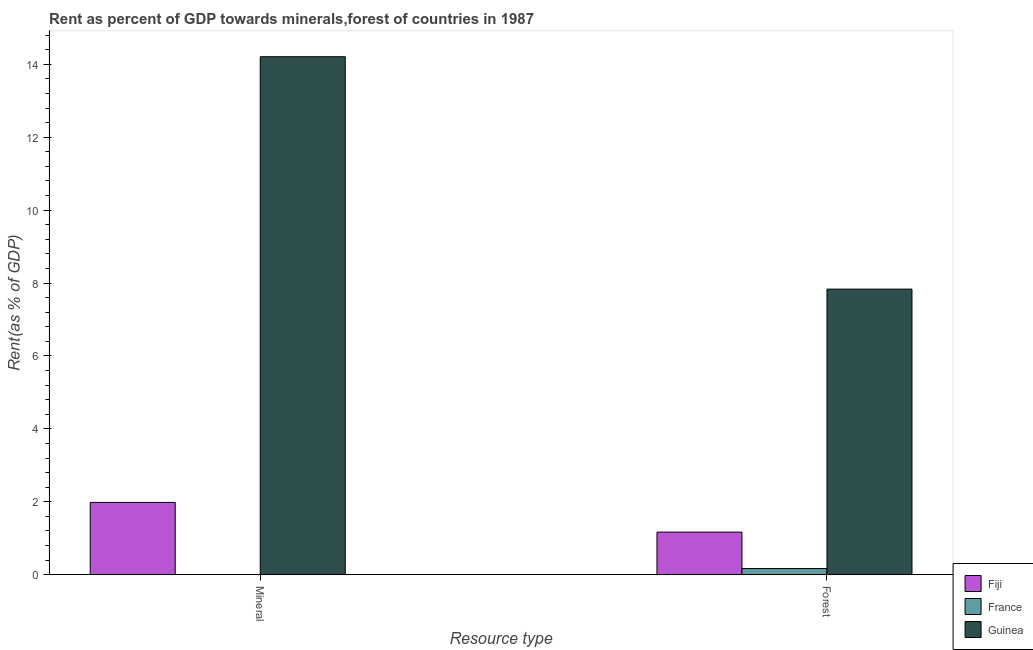How many different coloured bars are there?
Offer a very short reply. 3. How many groups of bars are there?
Offer a terse response. 2. Are the number of bars on each tick of the X-axis equal?
Your answer should be very brief. Yes. How many bars are there on the 1st tick from the left?
Offer a terse response. 3. How many bars are there on the 2nd tick from the right?
Provide a succinct answer. 3. What is the label of the 1st group of bars from the left?
Your answer should be compact. Mineral. What is the forest rent in France?
Provide a short and direct response. 0.17. Across all countries, what is the maximum forest rent?
Keep it short and to the point. 7.83. Across all countries, what is the minimum forest rent?
Provide a short and direct response. 0.17. In which country was the mineral rent maximum?
Give a very brief answer. Guinea. What is the total mineral rent in the graph?
Keep it short and to the point. 16.19. What is the difference between the forest rent in Guinea and that in Fiji?
Your response must be concise. 6.66. What is the difference between the mineral rent in Fiji and the forest rent in Guinea?
Ensure brevity in your answer.  -5.85. What is the average mineral rent per country?
Offer a very short reply. 5.4. What is the difference between the mineral rent and forest rent in Fiji?
Your answer should be compact. 0.81. What is the ratio of the forest rent in France to that in Guinea?
Make the answer very short. 0.02. What does the 3rd bar from the right in Forest represents?
Offer a terse response. Fiji. How many bars are there?
Provide a short and direct response. 6. How many countries are there in the graph?
Offer a terse response. 3. What is the difference between two consecutive major ticks on the Y-axis?
Keep it short and to the point. 2. Are the values on the major ticks of Y-axis written in scientific E-notation?
Make the answer very short. No. Where does the legend appear in the graph?
Ensure brevity in your answer.  Bottom right. How many legend labels are there?
Keep it short and to the point. 3. How are the legend labels stacked?
Provide a succinct answer. Vertical. What is the title of the graph?
Provide a succinct answer. Rent as percent of GDP towards minerals,forest of countries in 1987. What is the label or title of the X-axis?
Ensure brevity in your answer.  Resource type. What is the label or title of the Y-axis?
Keep it short and to the point. Rent(as % of GDP). What is the Rent(as % of GDP) in Fiji in Mineral?
Your answer should be compact. 1.98. What is the Rent(as % of GDP) in France in Mineral?
Your answer should be compact. 0. What is the Rent(as % of GDP) of Guinea in Mineral?
Make the answer very short. 14.21. What is the Rent(as % of GDP) in Fiji in Forest?
Give a very brief answer. 1.17. What is the Rent(as % of GDP) in France in Forest?
Provide a succinct answer. 0.17. What is the Rent(as % of GDP) in Guinea in Forest?
Your response must be concise. 7.83. Across all Resource type, what is the maximum Rent(as % of GDP) in Fiji?
Provide a short and direct response. 1.98. Across all Resource type, what is the maximum Rent(as % of GDP) in France?
Offer a very short reply. 0.17. Across all Resource type, what is the maximum Rent(as % of GDP) of Guinea?
Offer a very short reply. 14.21. Across all Resource type, what is the minimum Rent(as % of GDP) in Fiji?
Offer a terse response. 1.17. Across all Resource type, what is the minimum Rent(as % of GDP) of France?
Offer a terse response. 0. Across all Resource type, what is the minimum Rent(as % of GDP) in Guinea?
Provide a succinct answer. 7.83. What is the total Rent(as % of GDP) in Fiji in the graph?
Offer a terse response. 3.15. What is the total Rent(as % of GDP) in France in the graph?
Ensure brevity in your answer.  0.17. What is the total Rent(as % of GDP) of Guinea in the graph?
Your answer should be compact. 22.04. What is the difference between the Rent(as % of GDP) in Fiji in Mineral and that in Forest?
Give a very brief answer. 0.81. What is the difference between the Rent(as % of GDP) in France in Mineral and that in Forest?
Offer a very short reply. -0.17. What is the difference between the Rent(as % of GDP) of Guinea in Mineral and that in Forest?
Provide a succinct answer. 6.37. What is the difference between the Rent(as % of GDP) of Fiji in Mineral and the Rent(as % of GDP) of France in Forest?
Provide a succinct answer. 1.81. What is the difference between the Rent(as % of GDP) of Fiji in Mineral and the Rent(as % of GDP) of Guinea in Forest?
Provide a succinct answer. -5.85. What is the difference between the Rent(as % of GDP) in France in Mineral and the Rent(as % of GDP) in Guinea in Forest?
Your response must be concise. -7.83. What is the average Rent(as % of GDP) of Fiji per Resource type?
Provide a succinct answer. 1.57. What is the average Rent(as % of GDP) of France per Resource type?
Make the answer very short. 0.09. What is the average Rent(as % of GDP) in Guinea per Resource type?
Your answer should be very brief. 11.02. What is the difference between the Rent(as % of GDP) in Fiji and Rent(as % of GDP) in France in Mineral?
Your response must be concise. 1.98. What is the difference between the Rent(as % of GDP) of Fiji and Rent(as % of GDP) of Guinea in Mineral?
Offer a very short reply. -12.23. What is the difference between the Rent(as % of GDP) of France and Rent(as % of GDP) of Guinea in Mineral?
Ensure brevity in your answer.  -14.2. What is the difference between the Rent(as % of GDP) of Fiji and Rent(as % of GDP) of Guinea in Forest?
Your answer should be very brief. -6.67. What is the difference between the Rent(as % of GDP) of France and Rent(as % of GDP) of Guinea in Forest?
Give a very brief answer. -7.66. What is the ratio of the Rent(as % of GDP) in Fiji in Mineral to that in Forest?
Make the answer very short. 1.7. What is the ratio of the Rent(as % of GDP) in France in Mineral to that in Forest?
Your answer should be compact. 0.02. What is the ratio of the Rent(as % of GDP) in Guinea in Mineral to that in Forest?
Provide a succinct answer. 1.81. What is the difference between the highest and the second highest Rent(as % of GDP) in Fiji?
Your answer should be very brief. 0.81. What is the difference between the highest and the second highest Rent(as % of GDP) in France?
Your response must be concise. 0.17. What is the difference between the highest and the second highest Rent(as % of GDP) of Guinea?
Provide a succinct answer. 6.37. What is the difference between the highest and the lowest Rent(as % of GDP) of Fiji?
Offer a terse response. 0.81. What is the difference between the highest and the lowest Rent(as % of GDP) in France?
Offer a very short reply. 0.17. What is the difference between the highest and the lowest Rent(as % of GDP) in Guinea?
Provide a succinct answer. 6.37. 